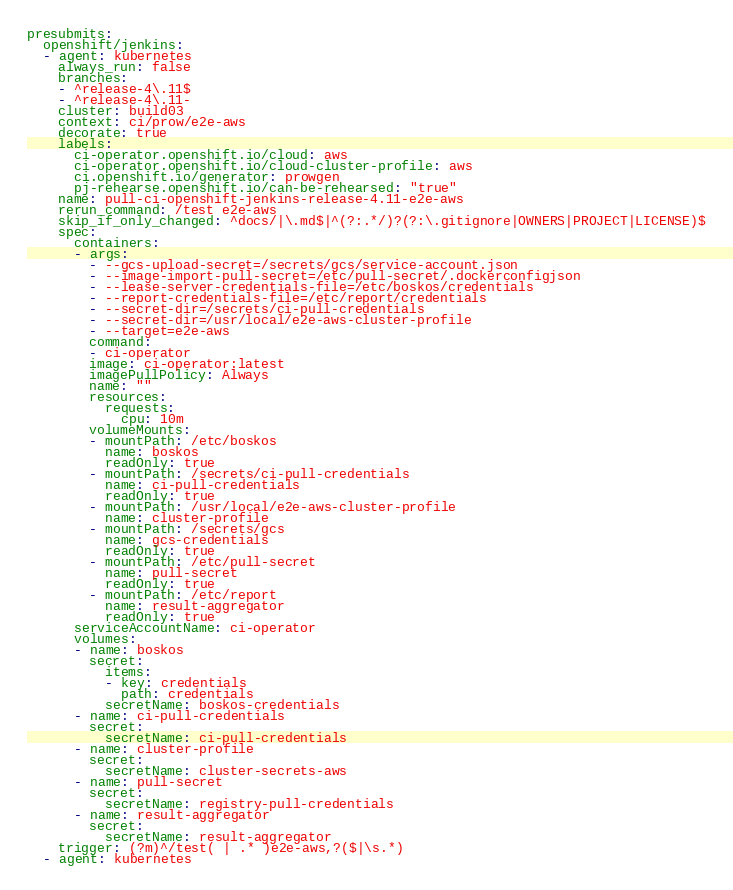<code> <loc_0><loc_0><loc_500><loc_500><_YAML_>presubmits:
  openshift/jenkins:
  - agent: kubernetes
    always_run: false
    branches:
    - ^release-4\.11$
    - ^release-4\.11-
    cluster: build03
    context: ci/prow/e2e-aws
    decorate: true
    labels:
      ci-operator.openshift.io/cloud: aws
      ci-operator.openshift.io/cloud-cluster-profile: aws
      ci.openshift.io/generator: prowgen
      pj-rehearse.openshift.io/can-be-rehearsed: "true"
    name: pull-ci-openshift-jenkins-release-4.11-e2e-aws
    rerun_command: /test e2e-aws
    skip_if_only_changed: ^docs/|\.md$|^(?:.*/)?(?:\.gitignore|OWNERS|PROJECT|LICENSE)$
    spec:
      containers:
      - args:
        - --gcs-upload-secret=/secrets/gcs/service-account.json
        - --image-import-pull-secret=/etc/pull-secret/.dockerconfigjson
        - --lease-server-credentials-file=/etc/boskos/credentials
        - --report-credentials-file=/etc/report/credentials
        - --secret-dir=/secrets/ci-pull-credentials
        - --secret-dir=/usr/local/e2e-aws-cluster-profile
        - --target=e2e-aws
        command:
        - ci-operator
        image: ci-operator:latest
        imagePullPolicy: Always
        name: ""
        resources:
          requests:
            cpu: 10m
        volumeMounts:
        - mountPath: /etc/boskos
          name: boskos
          readOnly: true
        - mountPath: /secrets/ci-pull-credentials
          name: ci-pull-credentials
          readOnly: true
        - mountPath: /usr/local/e2e-aws-cluster-profile
          name: cluster-profile
        - mountPath: /secrets/gcs
          name: gcs-credentials
          readOnly: true
        - mountPath: /etc/pull-secret
          name: pull-secret
          readOnly: true
        - mountPath: /etc/report
          name: result-aggregator
          readOnly: true
      serviceAccountName: ci-operator
      volumes:
      - name: boskos
        secret:
          items:
          - key: credentials
            path: credentials
          secretName: boskos-credentials
      - name: ci-pull-credentials
        secret:
          secretName: ci-pull-credentials
      - name: cluster-profile
        secret:
          secretName: cluster-secrets-aws
      - name: pull-secret
        secret:
          secretName: registry-pull-credentials
      - name: result-aggregator
        secret:
          secretName: result-aggregator
    trigger: (?m)^/test( | .* )e2e-aws,?($|\s.*)
  - agent: kubernetes</code> 